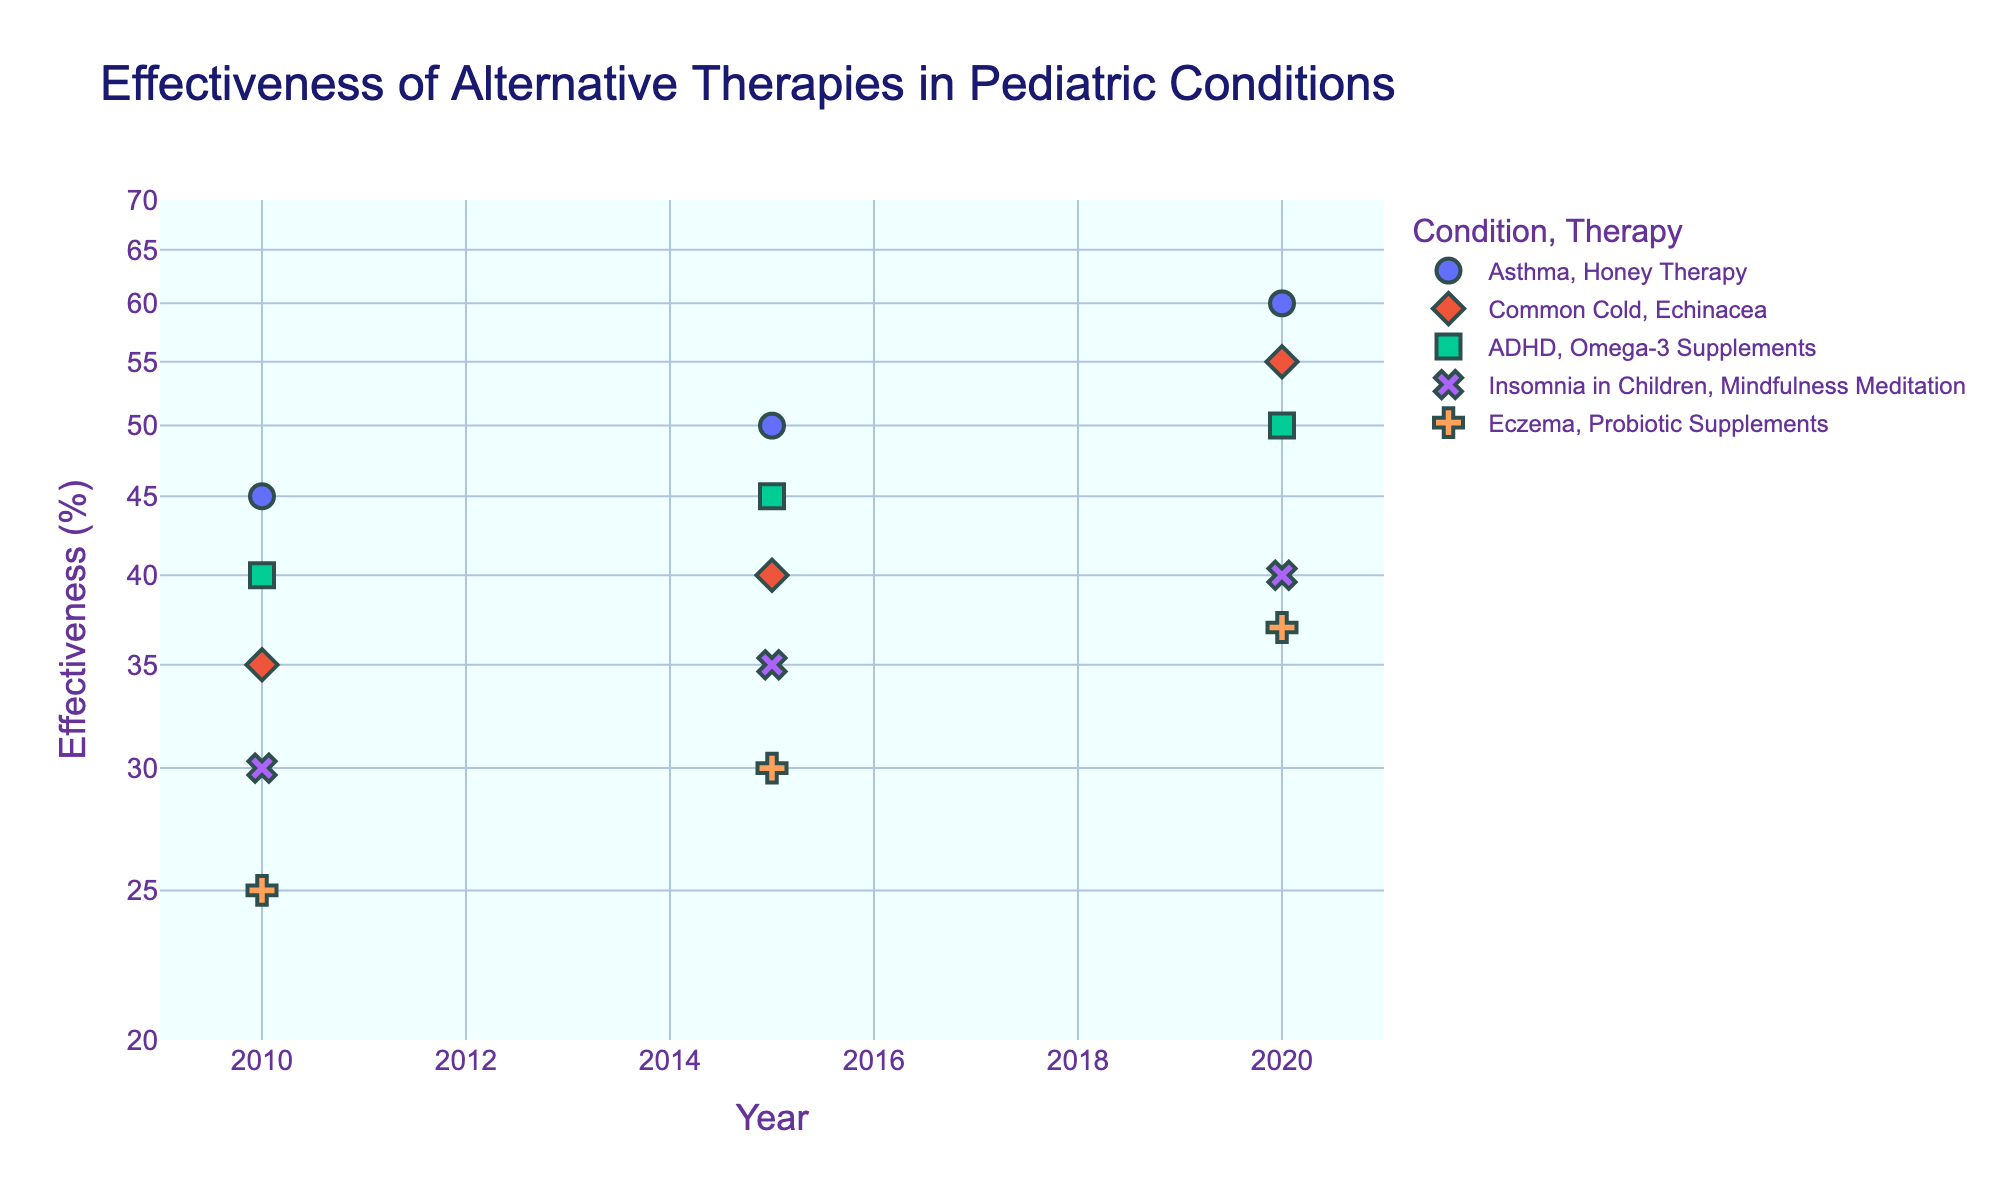Which condition has the highest average effectiveness of therapy over the years? We calculate the average effectiveness for each condition by summing up the effectiveness percentages for all years and then dividing by the number of years. Asthma has (45 + 50 + 60)/3 = 51.67, Common Cold has (35 + 40 + 55)/3 = 43.33, ADHD has (40 + 45 + 50)/3 = 45, Insomnia has (30 + 35 + 40)/3 = 35, and Eczema has (25 + 30 + 37)/3 = 30.67. Hence, Asthma has the highest average effectiveness of therapy.
Answer: Asthma Which therapy shows the greatest increase in effectiveness from 2010 to 2020? We need to find the difference in effectiveness from 2010 to 2020 for each therapy: Honey Therapy (60-45=15), Echinacea (55-35=20), Omega-3 Supplements (50-40=10), Mindfulness Meditation (40-30=10), and Probiotic Supplements (37-25=12). Echinacea shows the greatest increase in effectiveness.
Answer: Echinacea Which therapy for ADHD is represented in the scatter plot? By referring to the hover data on the scatter plot, we find that ADHD is treated with Omega-3 Supplements.
Answer: Omega-3 Supplements In which year did Echinacea for Common Cold show the highest effectiveness? We look at the data points corresponding to Echinacea for Common Cold in different years. The highest effectiveness is in 2020 with a value of 55.
Answer: 2020 Is there any condition whose therapy has decreasing effectiveness over the years? By analyzing the trend lines of each therapy, we see that all therapies show an increasing trend over the years. Thus, there is no condition with decreasing effectiveness.
Answer: No What is the difference in effectiveness between therapies for Insomnia in Children in 2010 and 2020? The effectiveness for Mindfulness Meditation in treating Insomnia in Children is 30 in 2010 and 40 in 2020. The difference is 40 - 30 = 10.
Answer: 10 What is the range of effectiveness percentages depicted in the scatter plot? We find the highest and lowest effectiveness values visible on the plot. The highest is 60 (Honey Therapy for Asthma in 2020) and the lowest is 25 (Probiotic Supplements for Eczema in 2010). Therefore, the range is 60 - 25 = 35.
Answer: 35 